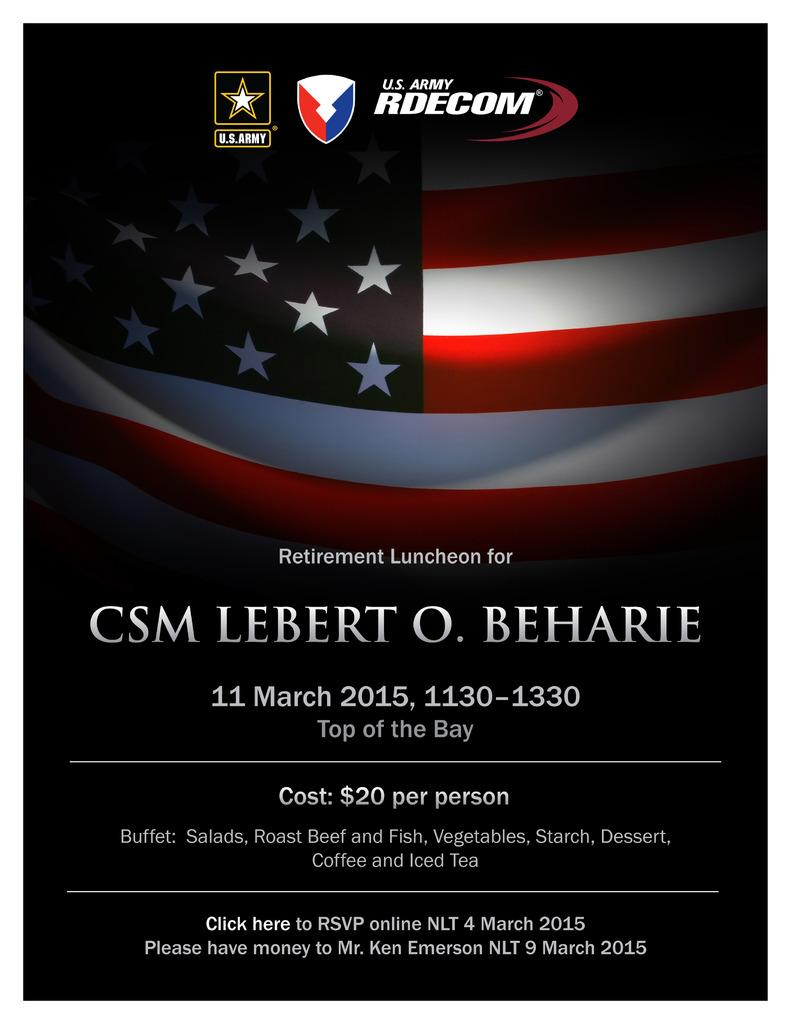What is the main subject of the image? The main subject of the image is an advertisement. What is depicted in the advertisement? The advertisement contains a picture of a flag. Are there any words on the advertisement? Yes, there is text on the advertisement. What type of hat is the person wearing in the image? There is no person wearing a hat in the image; it features an advertisement with a picture of a flag and text. 